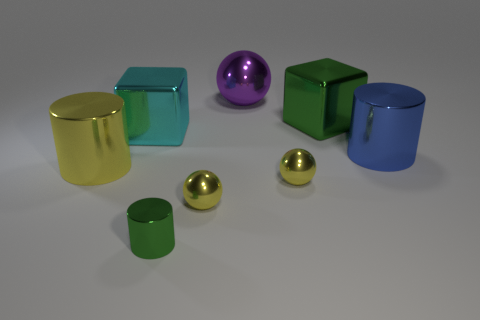Add 1 big blue metallic cylinders. How many objects exist? 9 Subtract all spheres. How many objects are left? 5 Subtract 2 yellow spheres. How many objects are left? 6 Subtract all purple metal things. Subtract all purple spheres. How many objects are left? 6 Add 5 large metal things. How many large metal things are left? 10 Add 2 small purple metallic things. How many small purple metallic things exist? 2 